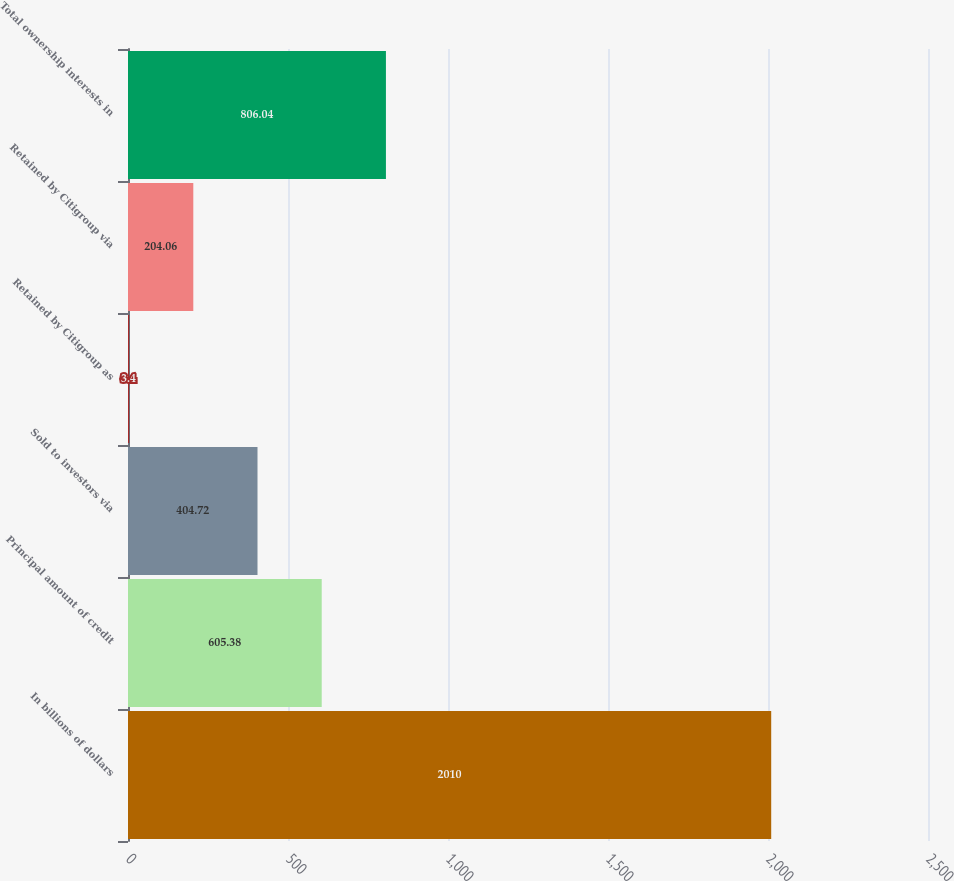Convert chart to OTSL. <chart><loc_0><loc_0><loc_500><loc_500><bar_chart><fcel>In billions of dollars<fcel>Principal amount of credit<fcel>Sold to investors via<fcel>Retained by Citigroup as<fcel>Retained by Citigroup via<fcel>Total ownership interests in<nl><fcel>2010<fcel>605.38<fcel>404.72<fcel>3.4<fcel>204.06<fcel>806.04<nl></chart> 